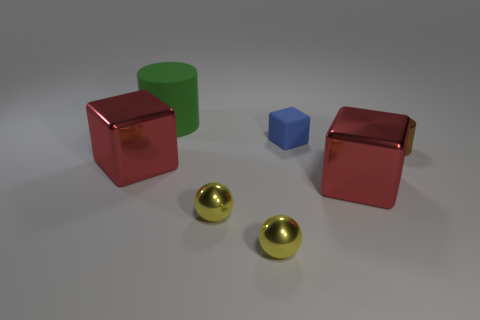There is a thing that is both behind the small brown shiny cylinder and in front of the large matte object; what color is it?
Your answer should be compact. Blue. Is there a purple block made of the same material as the blue object?
Your answer should be very brief. No. The green cylinder is what size?
Give a very brief answer. Large. There is a rubber cylinder behind the brown metal thing that is in front of the big green rubber cylinder; how big is it?
Offer a terse response. Large. There is a green object that is the same shape as the brown shiny thing; what is it made of?
Your answer should be compact. Rubber. How many yellow blocks are there?
Make the answer very short. 0. What is the color of the rubber block right of the big red object to the left of the red block that is to the right of the large green rubber object?
Your answer should be very brief. Blue. Is the number of small yellow matte spheres less than the number of large red objects?
Offer a very short reply. Yes. What color is the big matte object that is the same shape as the tiny brown thing?
Offer a very short reply. Green. There is a big thing that is the same material as the tiny blue thing; what color is it?
Give a very brief answer. Green. 